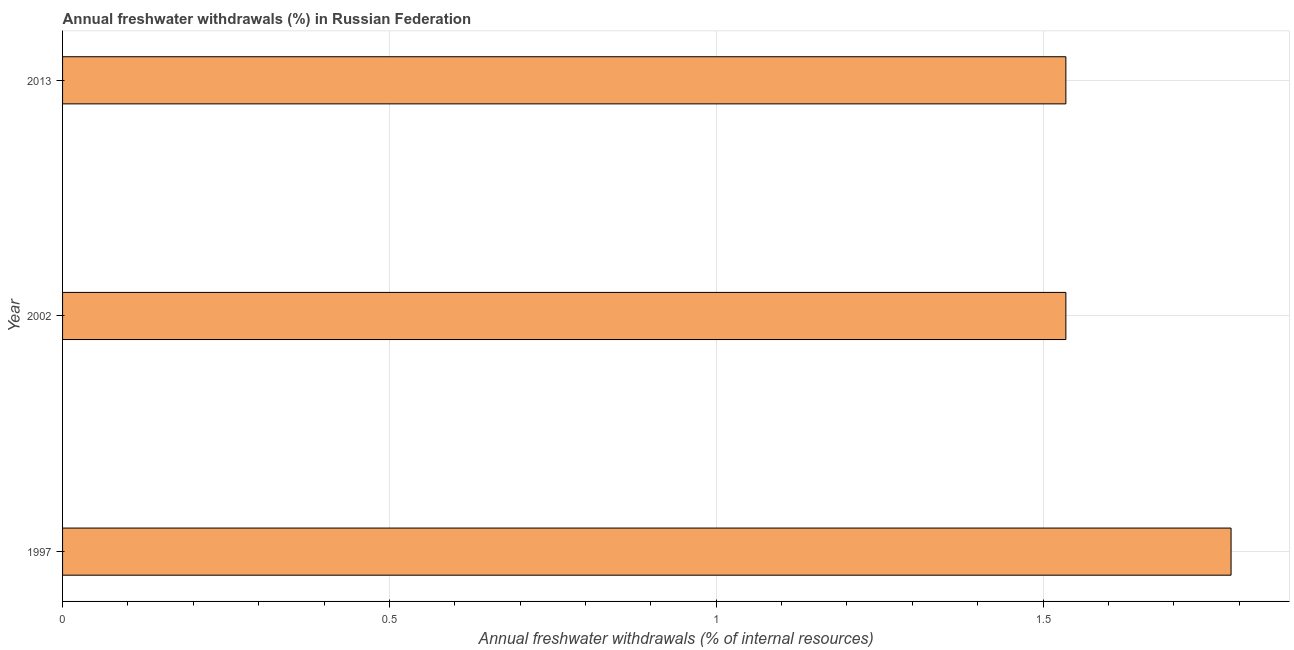Does the graph contain any zero values?
Keep it short and to the point. No. Does the graph contain grids?
Provide a short and direct response. Yes. What is the title of the graph?
Your response must be concise. Annual freshwater withdrawals (%) in Russian Federation. What is the label or title of the X-axis?
Your response must be concise. Annual freshwater withdrawals (% of internal resources). What is the annual freshwater withdrawals in 2013?
Keep it short and to the point. 1.53. Across all years, what is the maximum annual freshwater withdrawals?
Ensure brevity in your answer.  1.79. Across all years, what is the minimum annual freshwater withdrawals?
Offer a terse response. 1.53. In which year was the annual freshwater withdrawals maximum?
Ensure brevity in your answer.  1997. In which year was the annual freshwater withdrawals minimum?
Ensure brevity in your answer.  2002. What is the sum of the annual freshwater withdrawals?
Your answer should be very brief. 4.86. What is the average annual freshwater withdrawals per year?
Your response must be concise. 1.62. What is the median annual freshwater withdrawals?
Make the answer very short. 1.53. In how many years, is the annual freshwater withdrawals greater than 1 %?
Ensure brevity in your answer.  3. What is the ratio of the annual freshwater withdrawals in 2002 to that in 2013?
Give a very brief answer. 1. Is the annual freshwater withdrawals in 1997 less than that in 2013?
Your answer should be very brief. No. Is the difference between the annual freshwater withdrawals in 1997 and 2002 greater than the difference between any two years?
Your answer should be compact. Yes. What is the difference between the highest and the second highest annual freshwater withdrawals?
Provide a succinct answer. 0.25. Is the sum of the annual freshwater withdrawals in 1997 and 2002 greater than the maximum annual freshwater withdrawals across all years?
Give a very brief answer. Yes. What is the difference between the highest and the lowest annual freshwater withdrawals?
Ensure brevity in your answer.  0.25. Are the values on the major ticks of X-axis written in scientific E-notation?
Give a very brief answer. No. What is the Annual freshwater withdrawals (% of internal resources) in 1997?
Give a very brief answer. 1.79. What is the Annual freshwater withdrawals (% of internal resources) in 2002?
Keep it short and to the point. 1.53. What is the Annual freshwater withdrawals (% of internal resources) in 2013?
Keep it short and to the point. 1.53. What is the difference between the Annual freshwater withdrawals (% of internal resources) in 1997 and 2002?
Provide a short and direct response. 0.25. What is the difference between the Annual freshwater withdrawals (% of internal resources) in 1997 and 2013?
Offer a very short reply. 0.25. What is the difference between the Annual freshwater withdrawals (% of internal resources) in 2002 and 2013?
Ensure brevity in your answer.  0. What is the ratio of the Annual freshwater withdrawals (% of internal resources) in 1997 to that in 2002?
Give a very brief answer. 1.17. What is the ratio of the Annual freshwater withdrawals (% of internal resources) in 1997 to that in 2013?
Offer a very short reply. 1.17. 